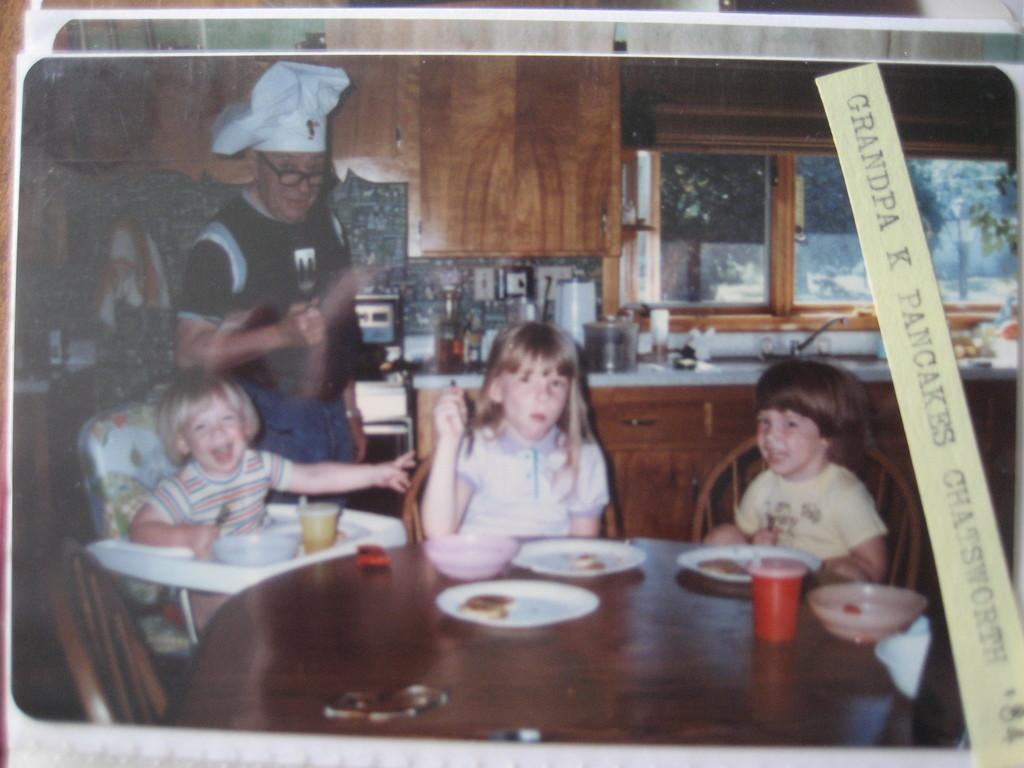In one or two sentences, can you explain what this image depicts? As we can see in the image there are tables, chairs, few people here and there, window, sink and on table there are plates, glasses and food items. 